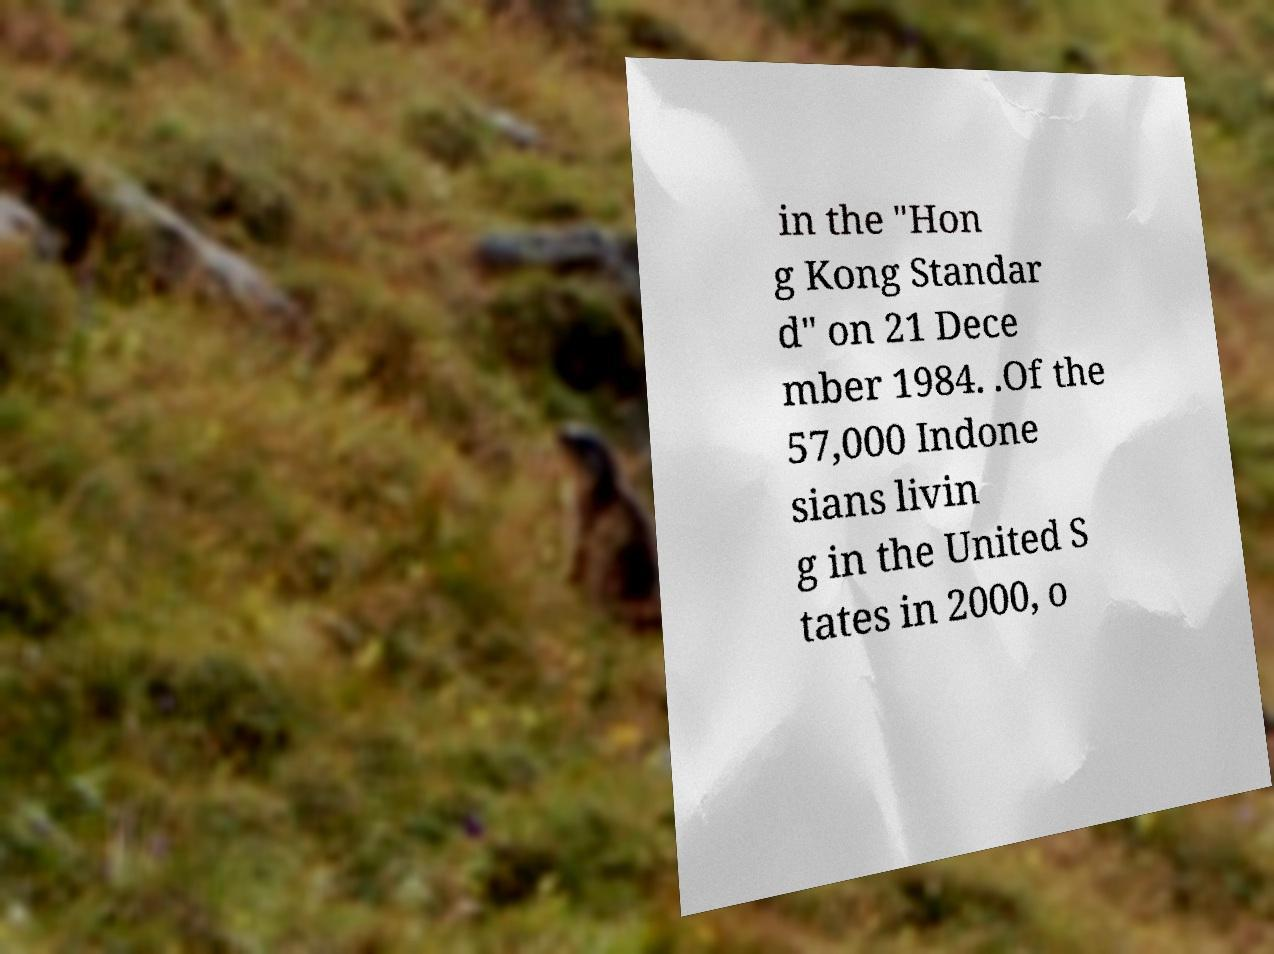There's text embedded in this image that I need extracted. Can you transcribe it verbatim? in the "Hon g Kong Standar d" on 21 Dece mber 1984. .Of the 57,000 Indone sians livin g in the United S tates in 2000, o 